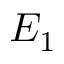Convert formula to latex. <formula><loc_0><loc_0><loc_500><loc_500>E _ { 1 }</formula> 